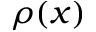Convert formula to latex. <formula><loc_0><loc_0><loc_500><loc_500>\rho ( x )</formula> 